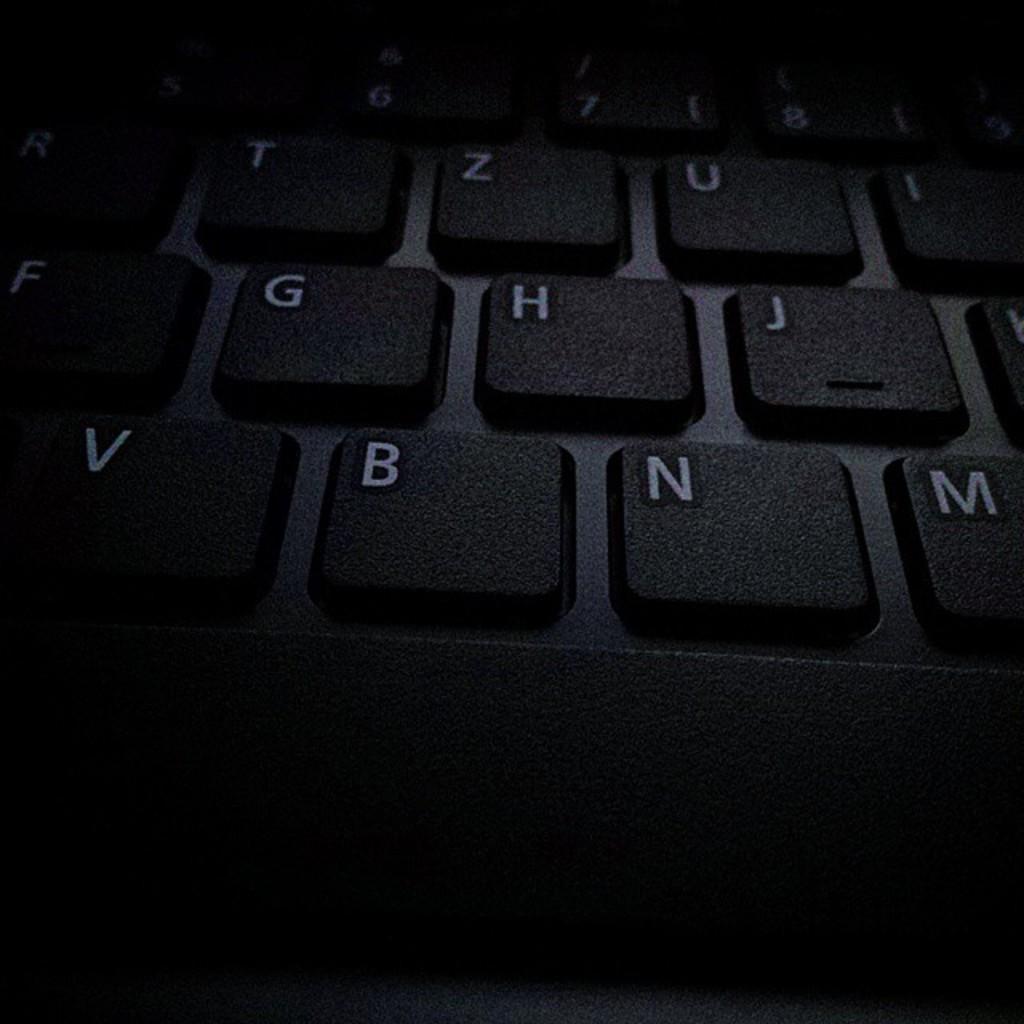How would you summarize this image in a sentence or two? In this image I can see the black color keyboard and few numbers and alphabets can be seen on it. 